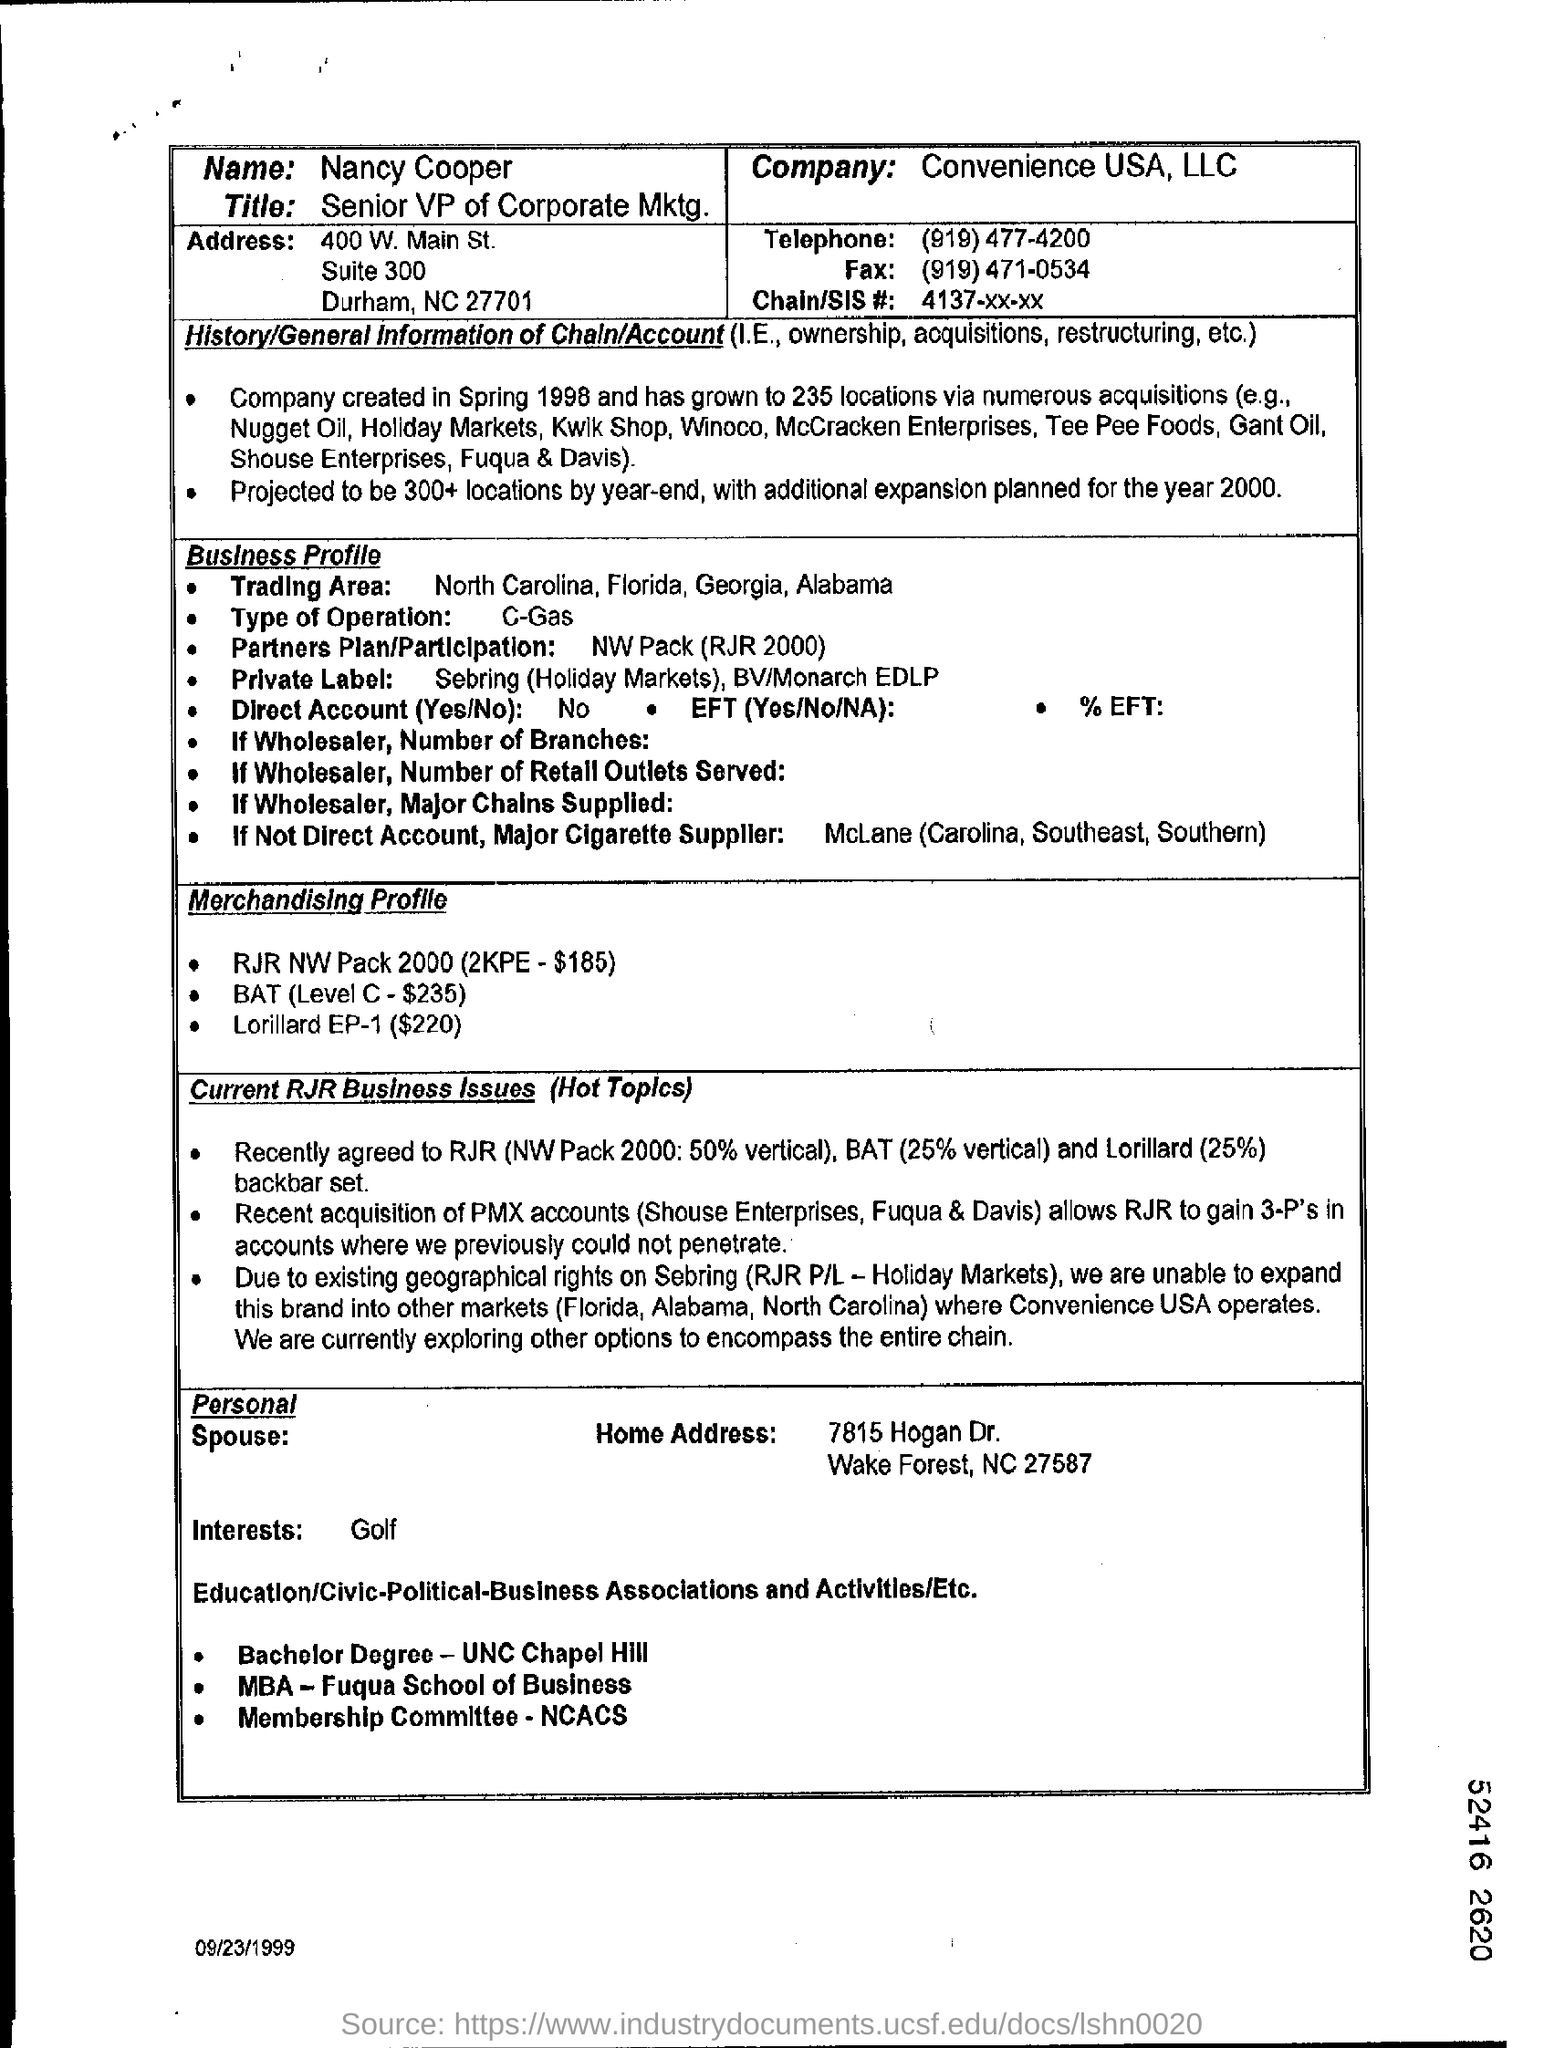Specify some key components in this picture. Convenience USA, LLC is the name of the company. The telephone number is (919) 477-4200. 